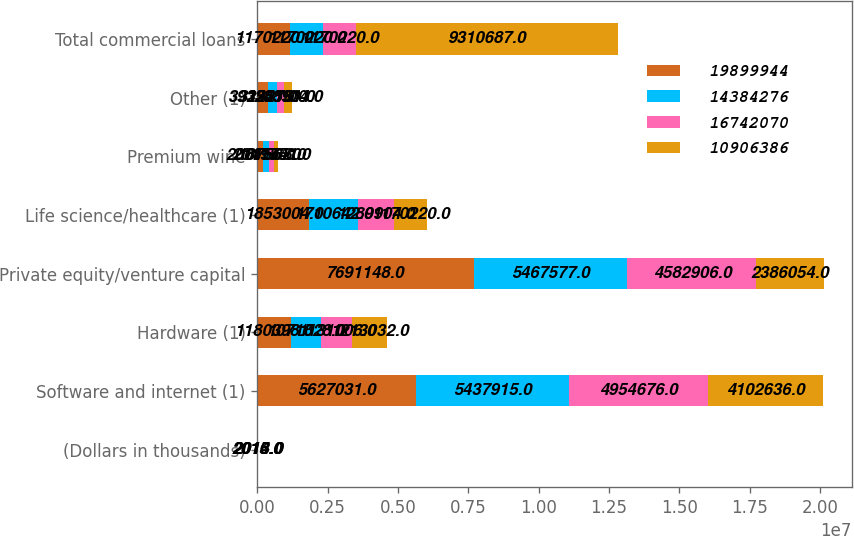Convert chart. <chart><loc_0><loc_0><loc_500><loc_500><stacked_bar_chart><ecel><fcel>(Dollars in thousands)<fcel>Software and internet (1)<fcel>Hardware (1)<fcel>Private equity/venture capital<fcel>Life science/healthcare (1)<fcel>Premium wine<fcel>Other (1)<fcel>Total commercial loans<nl><fcel>1.98999e+07<fcel>2016<fcel>5.62703e+06<fcel>1.1804e+06<fcel>7.69115e+06<fcel>1.853e+06<fcel>200156<fcel>393551<fcel>1.17022e+06<nl><fcel>1.43843e+07<fcel>2015<fcel>5.43792e+06<fcel>1.07153e+06<fcel>5.46758e+06<fcel>1.71064e+06<fcel>201175<fcel>312278<fcel>1.17022e+06<nl><fcel>1.67421e+07<fcel>2014<fcel>4.95468e+06<fcel>1.13101e+06<fcel>4.58291e+06<fcel>1.2899e+06<fcel>187568<fcel>234551<fcel>1.17022e+06<nl><fcel>1.09064e+07<fcel>2013<fcel>4.10264e+06<fcel>1.21303e+06<fcel>2.38605e+06<fcel>1.17022e+06<fcel>149841<fcel>288904<fcel>9.31069e+06<nl></chart> 